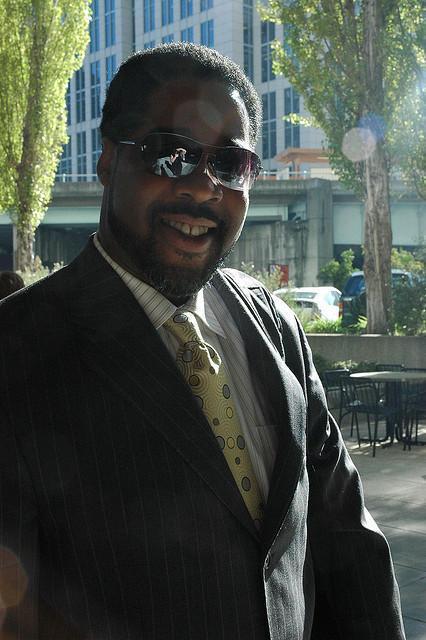How many ties are in the photo?
Give a very brief answer. 1. How many people are in the photo?
Give a very brief answer. 1. 